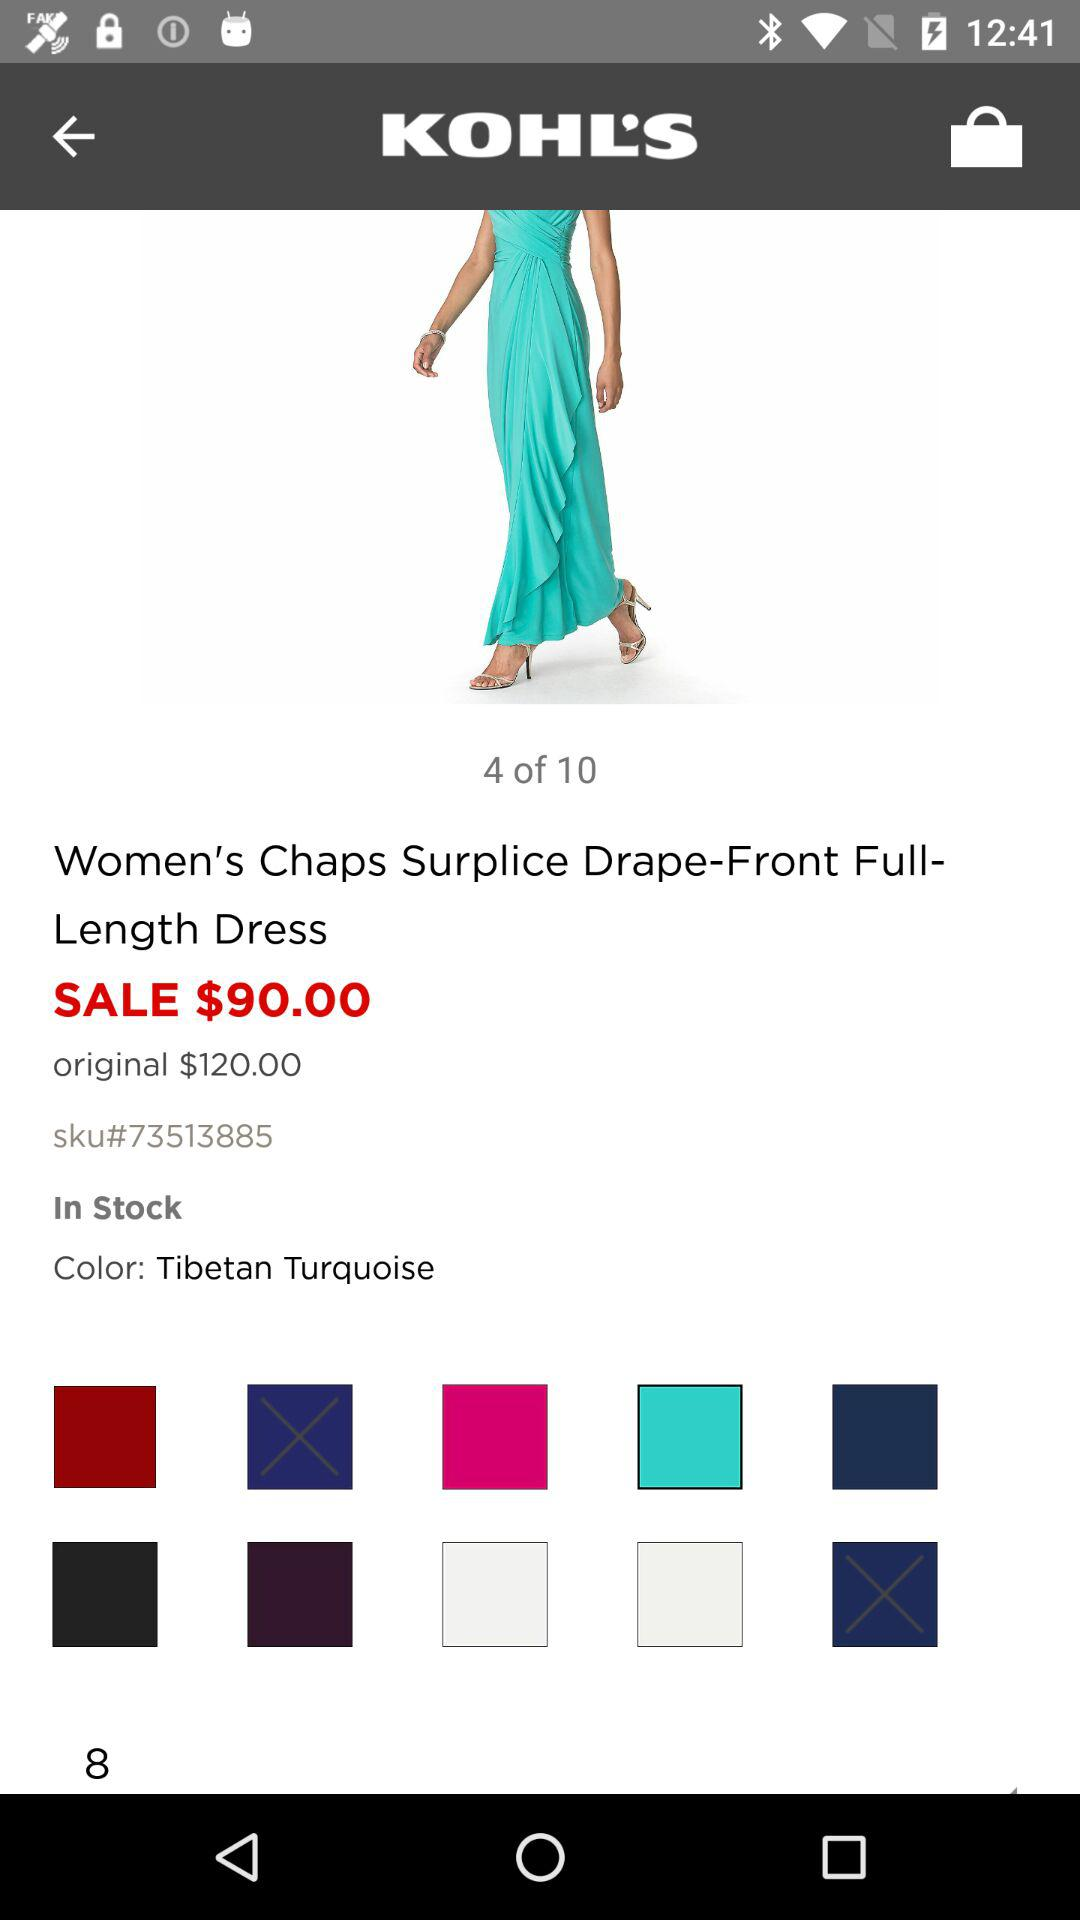What is the sale price? The sale price is $90. 